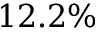<formula> <loc_0><loc_0><loc_500><loc_500>1 2 . 2 \%</formula> 